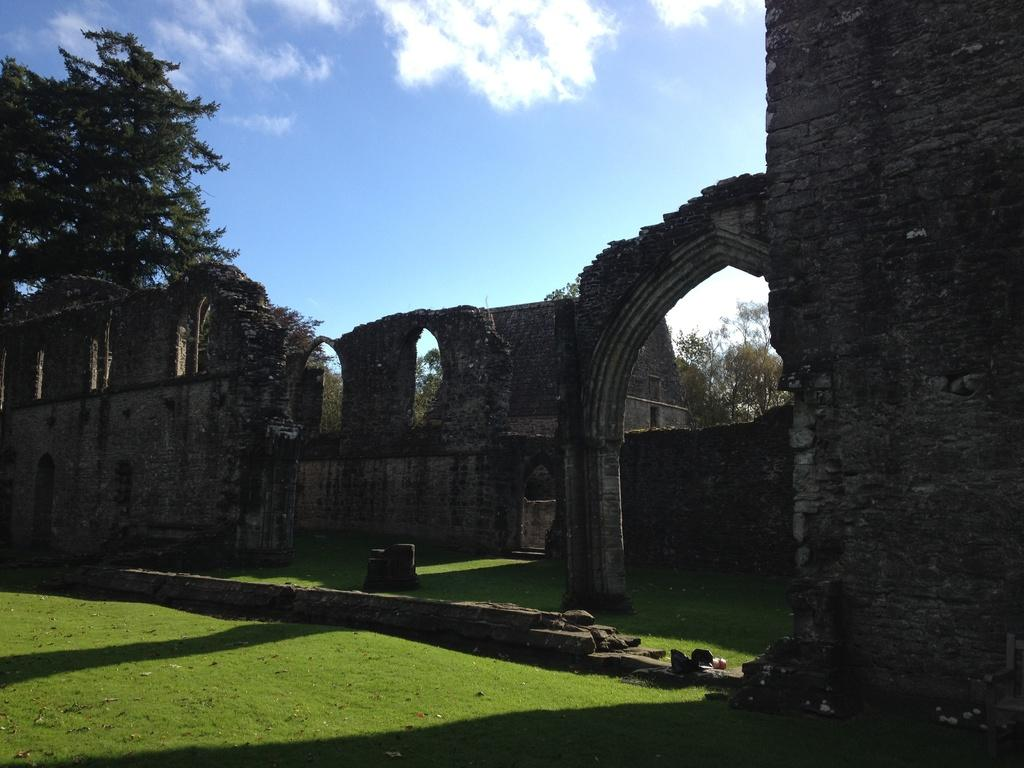What type of structures can be seen in the image? There are walls visible in the image. What is located behind the walls? Trees are visible behind the walls. What is visible at the top of the image? The sky is visible at the top of the image. What type of vegetation is present at the bottom of the image? Grass is present at the bottom of the image. What game is being played in the image? There is no game being played in the image; it primarily features walls, trees, sky, and grass. 